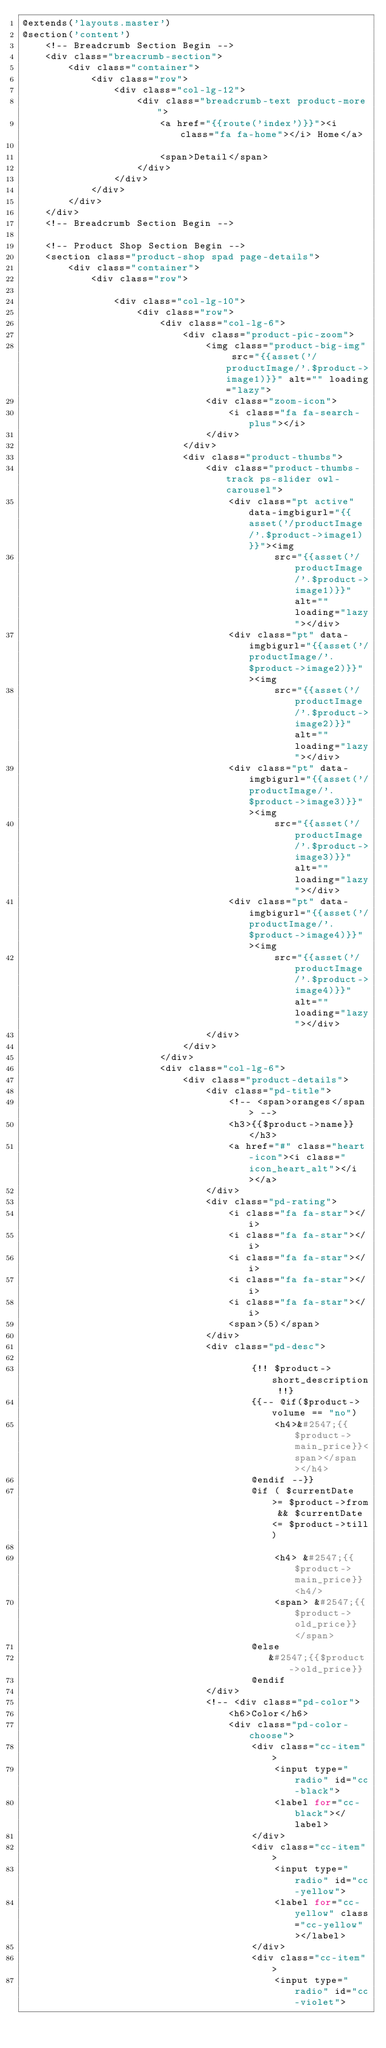<code> <loc_0><loc_0><loc_500><loc_500><_PHP_>@extends('layouts.master')
@section('content')
    <!-- Breadcrumb Section Begin -->
    <div class="breacrumb-section">
        <div class="container">
            <div class="row">
                <div class="col-lg-12">
                    <div class="breadcrumb-text product-more">
                        <a href="{{route('index')}}"><i class="fa fa-home"></i> Home</a>

                        <span>Detail</span>
                    </div>
                </div>
            </div>
        </div>
    </div>
    <!-- Breadcrumb Section Begin -->

    <!-- Product Shop Section Begin -->
    <section class="product-shop spad page-details">
        <div class="container">
            <div class="row">

                <div class="col-lg-10">
                    <div class="row">
                        <div class="col-lg-6">
                            <div class="product-pic-zoom">
                                <img class="product-big-img" src="{{asset('/productImage/'.$product->image1)}}" alt="" loading="lazy">
                                <div class="zoom-icon">
                                    <i class="fa fa-search-plus"></i>
                                </div>
                            </div>
                            <div class="product-thumbs">
                                <div class="product-thumbs-track ps-slider owl-carousel">
                                    <div class="pt active" data-imgbigurl="{{asset('/productImage/'.$product->image1)}}"><img
                                            src="{{asset('/productImage/'.$product->image1)}}" alt="" loading="lazy"></div>
                                    <div class="pt" data-imgbigurl="{{asset('/productImage/'.$product->image2)}}"><img
                                            src="{{asset('/productImage/'.$product->image2)}}" alt="" loading="lazy"></div>
                                    <div class="pt" data-imgbigurl="{{asset('/productImage/'.$product->image3)}}"><img
                                            src="{{asset('/productImage/'.$product->image3)}}" alt="" loading="lazy"></div>
                                    <div class="pt" data-imgbigurl="{{asset('/productImage/'.$product->image4)}}"><img
                                            src="{{asset('/productImage/'.$product->image4)}}" alt="" loading="lazy"></div>
                                </div>
                            </div>
                        </div>
                        <div class="col-lg-6">
                            <div class="product-details">
                                <div class="pd-title">
                                    <!-- <span>oranges</span> -->
                                    <h3>{{$product->name}} </h3>
                                    <a href="#" class="heart-icon"><i class="icon_heart_alt"></i></a>
                                </div>
                                <div class="pd-rating">
                                    <i class="fa fa-star"></i>
                                    <i class="fa fa-star"></i>
                                    <i class="fa fa-star"></i>
                                    <i class="fa fa-star"></i>
                                    <i class="fa fa-star"></i>
                                    <span>(5)</span>
                                </div>
                                <div class="pd-desc">

                                        {!! $product->short_description !!}
                                        {{-- @if($product->volume == "no")
                                            <h4>&#2547;{{$product->main_price}}<span></span></h4>
                                        @endif --}}
                                        @if ( $currentDate >= $product->from && $currentDate <= $product->till)

                                            <h4> &#2547;{{$product->main_price}} <h4/>
                                            <span> &#2547;{{$product->old_price}} </span>
                                        @else
                                           &#2547;{{$product->old_price}}
                                        @endif
                                </div>
                                <!-- <div class="pd-color">
                                    <h6>Color</h6>
                                    <div class="pd-color-choose">
                                        <div class="cc-item">
                                            <input type="radio" id="cc-black">
                                            <label for="cc-black"></label>
                                        </div>
                                        <div class="cc-item">
                                            <input type="radio" id="cc-yellow">
                                            <label for="cc-yellow" class="cc-yellow"></label>
                                        </div>
                                        <div class="cc-item">
                                            <input type="radio" id="cc-violet"></code> 